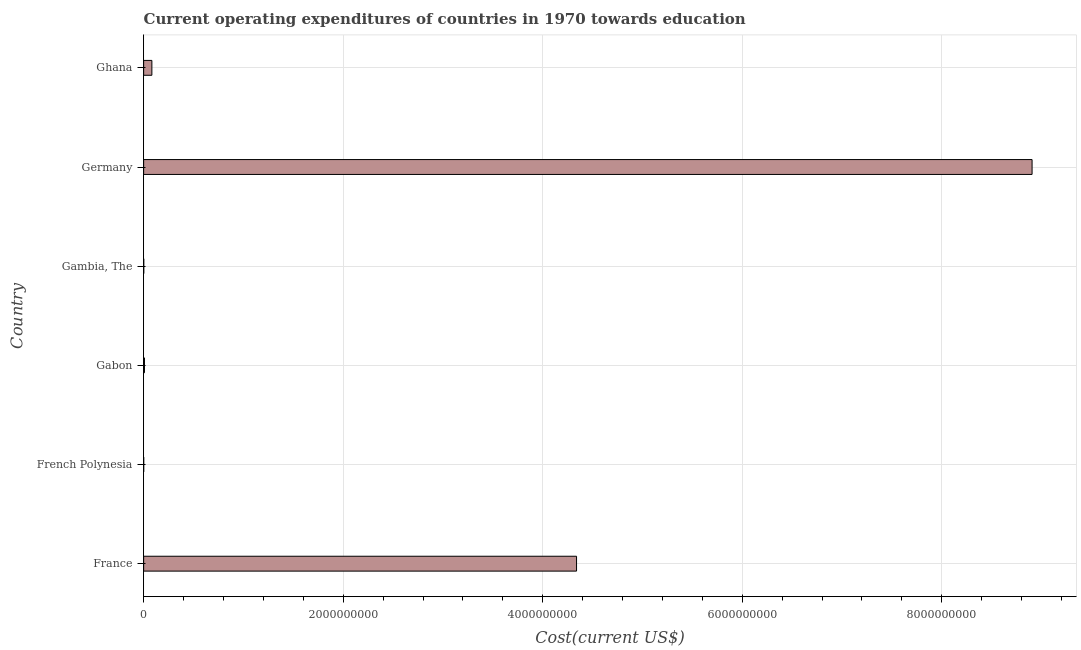Does the graph contain any zero values?
Offer a very short reply. No. Does the graph contain grids?
Your response must be concise. Yes. What is the title of the graph?
Offer a very short reply. Current operating expenditures of countries in 1970 towards education. What is the label or title of the X-axis?
Give a very brief answer. Cost(current US$). What is the label or title of the Y-axis?
Keep it short and to the point. Country. What is the education expenditure in Gabon?
Provide a short and direct response. 8.29e+06. Across all countries, what is the maximum education expenditure?
Make the answer very short. 8.90e+09. Across all countries, what is the minimum education expenditure?
Keep it short and to the point. 6.30e+05. In which country was the education expenditure minimum?
Offer a very short reply. French Polynesia. What is the sum of the education expenditure?
Make the answer very short. 1.33e+1. What is the difference between the education expenditure in Gambia, The and Ghana?
Provide a succinct answer. -8.13e+07. What is the average education expenditure per country?
Give a very brief answer. 2.22e+09. What is the median education expenditure?
Your response must be concise. 4.54e+07. In how many countries, is the education expenditure greater than 4800000000 US$?
Keep it short and to the point. 1. What is the ratio of the education expenditure in France to that in Gabon?
Your answer should be compact. 523.2. Is the difference between the education expenditure in Gabon and Germany greater than the difference between any two countries?
Make the answer very short. No. What is the difference between the highest and the second highest education expenditure?
Make the answer very short. 4.57e+09. What is the difference between the highest and the lowest education expenditure?
Keep it short and to the point. 8.90e+09. In how many countries, is the education expenditure greater than the average education expenditure taken over all countries?
Offer a terse response. 2. How many bars are there?
Your answer should be very brief. 6. Are all the bars in the graph horizontal?
Provide a short and direct response. Yes. How many countries are there in the graph?
Your response must be concise. 6. What is the difference between two consecutive major ticks on the X-axis?
Give a very brief answer. 2.00e+09. What is the Cost(current US$) of France?
Ensure brevity in your answer.  4.34e+09. What is the Cost(current US$) of French Polynesia?
Offer a terse response. 6.30e+05. What is the Cost(current US$) of Gabon?
Offer a terse response. 8.29e+06. What is the Cost(current US$) in Gambia, The?
Provide a short and direct response. 1.15e+06. What is the Cost(current US$) of Germany?
Your response must be concise. 8.90e+09. What is the Cost(current US$) in Ghana?
Offer a very short reply. 8.25e+07. What is the difference between the Cost(current US$) in France and French Polynesia?
Offer a very short reply. 4.34e+09. What is the difference between the Cost(current US$) in France and Gabon?
Your response must be concise. 4.33e+09. What is the difference between the Cost(current US$) in France and Gambia, The?
Ensure brevity in your answer.  4.34e+09. What is the difference between the Cost(current US$) in France and Germany?
Your answer should be very brief. -4.57e+09. What is the difference between the Cost(current US$) in France and Ghana?
Your answer should be compact. 4.26e+09. What is the difference between the Cost(current US$) in French Polynesia and Gabon?
Provide a short and direct response. -7.66e+06. What is the difference between the Cost(current US$) in French Polynesia and Gambia, The?
Offer a very short reply. -5.21e+05. What is the difference between the Cost(current US$) in French Polynesia and Germany?
Your answer should be very brief. -8.90e+09. What is the difference between the Cost(current US$) in French Polynesia and Ghana?
Make the answer very short. -8.19e+07. What is the difference between the Cost(current US$) in Gabon and Gambia, The?
Your answer should be very brief. 7.14e+06. What is the difference between the Cost(current US$) in Gabon and Germany?
Your response must be concise. -8.90e+09. What is the difference between the Cost(current US$) in Gabon and Ghana?
Your answer should be compact. -7.42e+07. What is the difference between the Cost(current US$) in Gambia, The and Germany?
Give a very brief answer. -8.90e+09. What is the difference between the Cost(current US$) in Gambia, The and Ghana?
Ensure brevity in your answer.  -8.13e+07. What is the difference between the Cost(current US$) in Germany and Ghana?
Offer a terse response. 8.82e+09. What is the ratio of the Cost(current US$) in France to that in French Polynesia?
Your answer should be compact. 6889.52. What is the ratio of the Cost(current US$) in France to that in Gabon?
Ensure brevity in your answer.  523.2. What is the ratio of the Cost(current US$) in France to that in Gambia, The?
Offer a very short reply. 3771.39. What is the ratio of the Cost(current US$) in France to that in Germany?
Your response must be concise. 0.49. What is the ratio of the Cost(current US$) in France to that in Ghana?
Provide a short and direct response. 52.6. What is the ratio of the Cost(current US$) in French Polynesia to that in Gabon?
Your answer should be very brief. 0.08. What is the ratio of the Cost(current US$) in French Polynesia to that in Gambia, The?
Keep it short and to the point. 0.55. What is the ratio of the Cost(current US$) in French Polynesia to that in Germany?
Keep it short and to the point. 0. What is the ratio of the Cost(current US$) in French Polynesia to that in Ghana?
Your answer should be very brief. 0.01. What is the ratio of the Cost(current US$) in Gabon to that in Gambia, The?
Provide a short and direct response. 7.21. What is the ratio of the Cost(current US$) in Gabon to that in Germany?
Your response must be concise. 0. What is the ratio of the Cost(current US$) in Gabon to that in Ghana?
Provide a succinct answer. 0.1. What is the ratio of the Cost(current US$) in Gambia, The to that in Germany?
Your answer should be compact. 0. What is the ratio of the Cost(current US$) in Gambia, The to that in Ghana?
Provide a succinct answer. 0.01. What is the ratio of the Cost(current US$) in Germany to that in Ghana?
Provide a succinct answer. 107.95. 